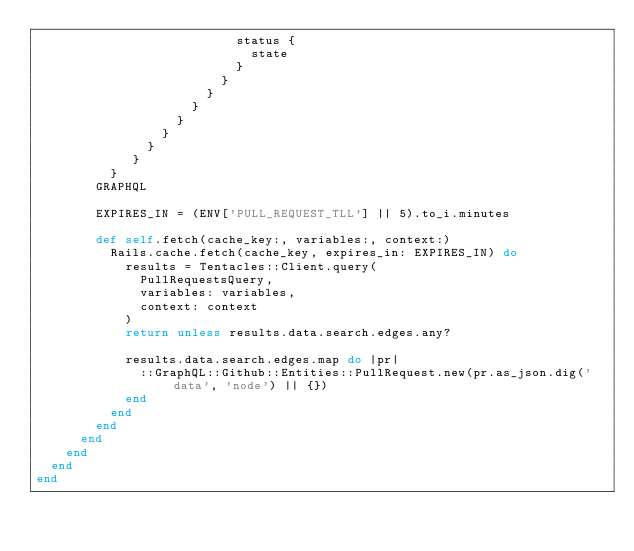<code> <loc_0><loc_0><loc_500><loc_500><_Ruby_>                           status {
                             state
                           }
                         }
                       }
                     }
                   }
                 }
               }
             }
          }
        GRAPHQL

        EXPIRES_IN = (ENV['PULL_REQUEST_TLL'] || 5).to_i.minutes

        def self.fetch(cache_key:, variables:, context:)
          Rails.cache.fetch(cache_key, expires_in: EXPIRES_IN) do
            results = Tentacles::Client.query(
              PullRequestsQuery,
              variables: variables,
              context: context
            )
            return unless results.data.search.edges.any?

            results.data.search.edges.map do |pr|
              ::GraphQL::Github::Entities::PullRequest.new(pr.as_json.dig('data', 'node') || {})
            end
          end
        end
      end
    end
  end
end
</code> 